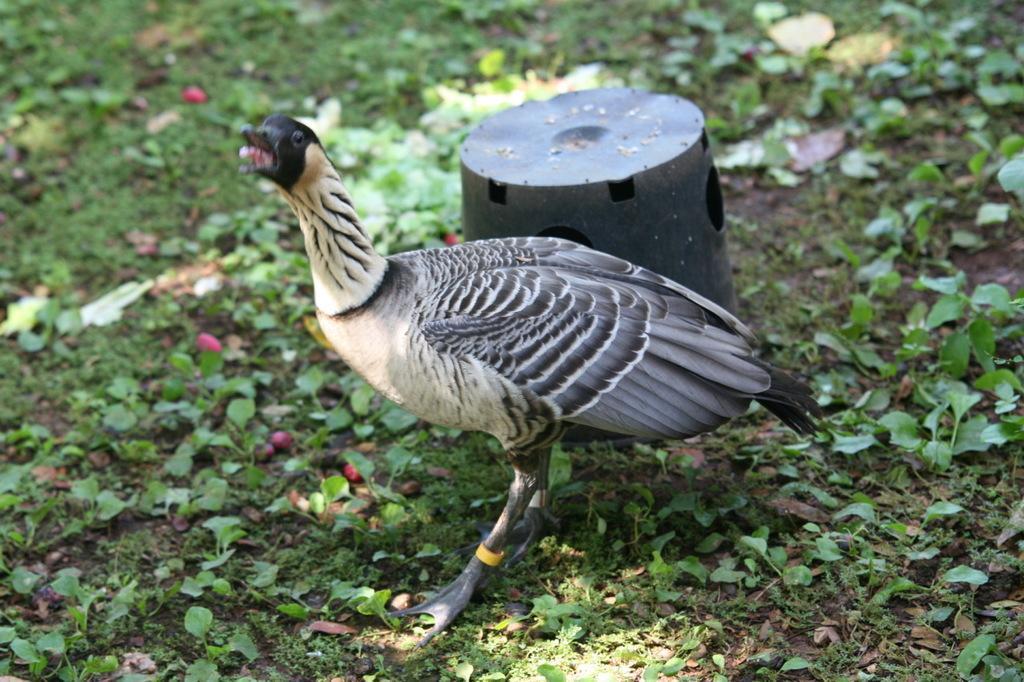How would you summarize this image in a sentence or two? In this image we can see a bird which is in white and black color and in the background of the image there is a thing which is in black color and we can see some leaves which are in black color. 